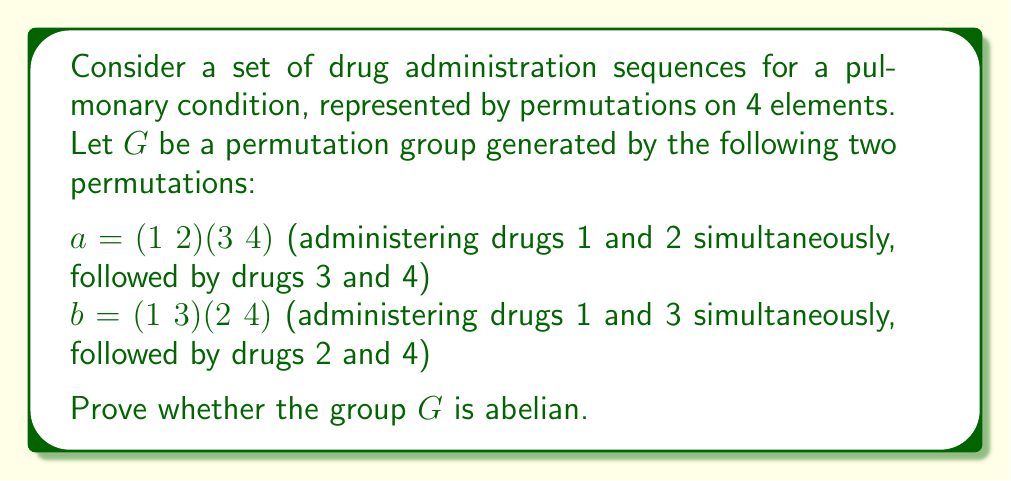Give your solution to this math problem. To prove whether the group $G$ is abelian, we need to check if all elements in the group commute with each other. Since $G$ is generated by $a$ and $b$, it's sufficient to check if $ab = ba$.

Let's compute $ab$ and $ba$:

1) Computing $ab$:
   $ab = (1 2)(3 4) \circ (1 3)(2 4)$
   
   Apply $(1 3)(2 4)$ first, then $(1 2)(3 4)$:
   $1 \rightarrow 3 \rightarrow 4$
   $2 \rightarrow 4 \rightarrow 3$
   $3 \rightarrow 1 \rightarrow 2$
   $4 \rightarrow 2 \rightarrow 1$
   
   Therefore, $ab = (1 4 3 2)$

2) Computing $ba$:
   $ba = (1 3)(2 4) \circ (1 2)(3 4)$
   
   Apply $(1 2)(3 4)$ first, then $(1 3)(2 4)$:
   $1 \rightarrow 2 \rightarrow 4$
   $2 \rightarrow 1 \rightarrow 3$
   $3 \rightarrow 4 \rightarrow 2$
   $4 \rightarrow 3 \rightarrow 1$
   
   Therefore, $ba = (1 4)(2 3)$

Since $ab \neq ba$, the group $G$ is not abelian.

From a pharmacological perspective, this result implies that the order of drug administration in these sequences matters. For example, administering drugs 1 and 2 simultaneously followed by drugs 3 and 4 (represented by $a$), and then administering drugs 1 and 3 simultaneously followed by drugs 2 and 4 (represented by $b$) results in a different overall effect compared to administering the sequences in the reverse order.
Answer: The group $G$ is not abelian because $ab \neq ba$. Specifically, $ab = (1 4 3 2)$ while $ba = (1 4)(2 3)$. 